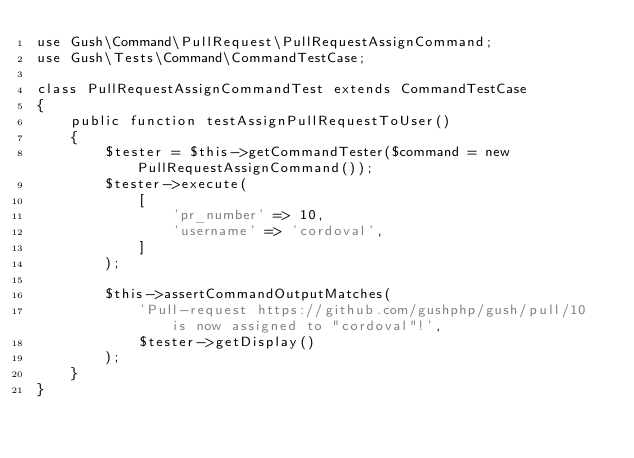<code> <loc_0><loc_0><loc_500><loc_500><_PHP_>use Gush\Command\PullRequest\PullRequestAssignCommand;
use Gush\Tests\Command\CommandTestCase;

class PullRequestAssignCommandTest extends CommandTestCase
{
    public function testAssignPullRequestToUser()
    {
        $tester = $this->getCommandTester($command = new PullRequestAssignCommand());
        $tester->execute(
            [
                'pr_number' => 10,
                'username' => 'cordoval',
            ]
        );

        $this->assertCommandOutputMatches(
            'Pull-request https://github.com/gushphp/gush/pull/10 is now assigned to "cordoval"!',
            $tester->getDisplay()
        );
    }
}
</code> 